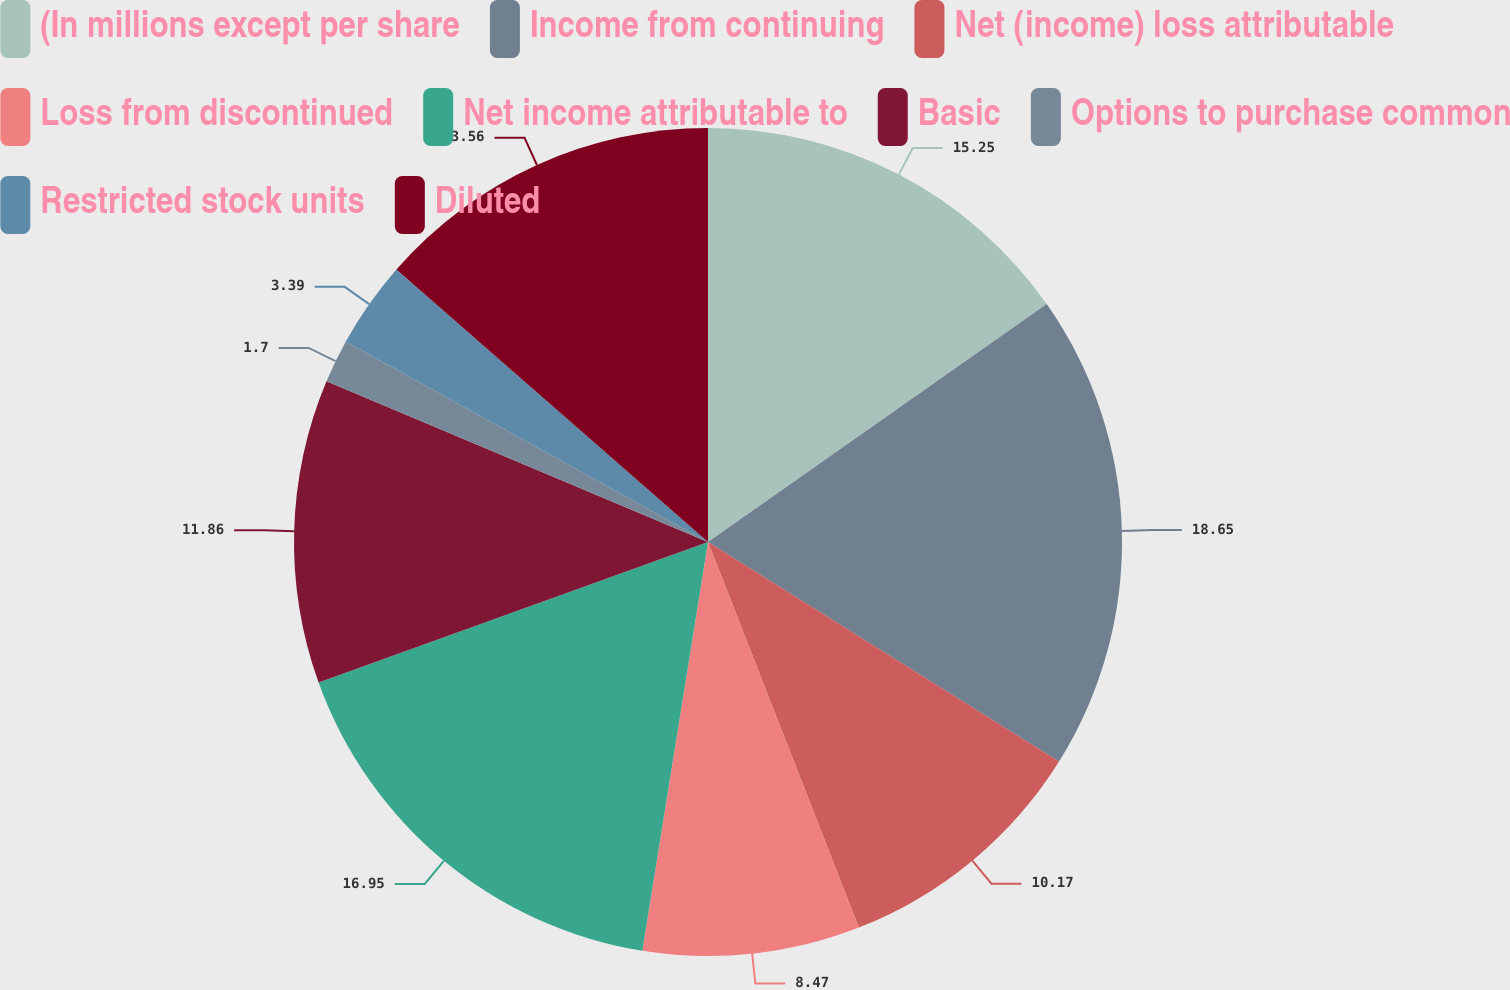Convert chart. <chart><loc_0><loc_0><loc_500><loc_500><pie_chart><fcel>(In millions except per share<fcel>Income from continuing<fcel>Net (income) loss attributable<fcel>Loss from discontinued<fcel>Net income attributable to<fcel>Basic<fcel>Options to purchase common<fcel>Restricted stock units<fcel>Diluted<nl><fcel>15.25%<fcel>18.64%<fcel>10.17%<fcel>8.47%<fcel>16.95%<fcel>11.86%<fcel>1.7%<fcel>3.39%<fcel>13.56%<nl></chart> 